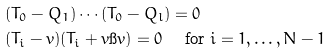Convert formula to latex. <formula><loc_0><loc_0><loc_500><loc_500>& ( T _ { 0 } - Q _ { 1 } ) \cdots ( T _ { 0 } - Q _ { l } ) = 0 \\ & ( T _ { i } - v ) ( T _ { i } + v \i v ) = 0 \quad \text { for $i = 1, \dots, N-1$}</formula> 